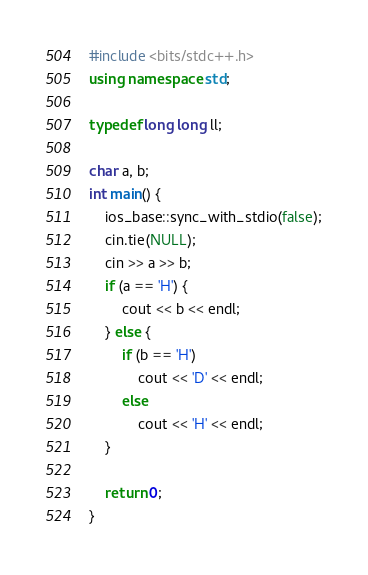Convert code to text. <code><loc_0><loc_0><loc_500><loc_500><_C++_>
#include <bits/stdc++.h>
using namespace std;

typedef long long ll;

char a, b;
int main() {
    ios_base::sync_with_stdio(false);
    cin.tie(NULL);
    cin >> a >> b;
    if (a == 'H') {
        cout << b << endl;
    } else {
        if (b == 'H')
            cout << 'D' << endl;
        else
            cout << 'H' << endl;
    }

    return 0;
}

</code> 